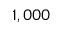Convert formula to latex. <formula><loc_0><loc_0><loc_500><loc_500>1 , 0 0 0</formula> 